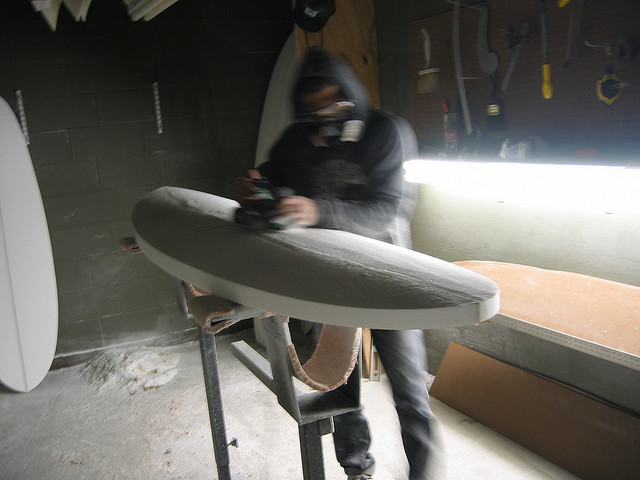What is the man doing in the photograph? The man is shaping a surfboard, a skilled craft that involves carefully contouring the board's foam to the desired shape using a variety of tools such as the power planer he's handling. 